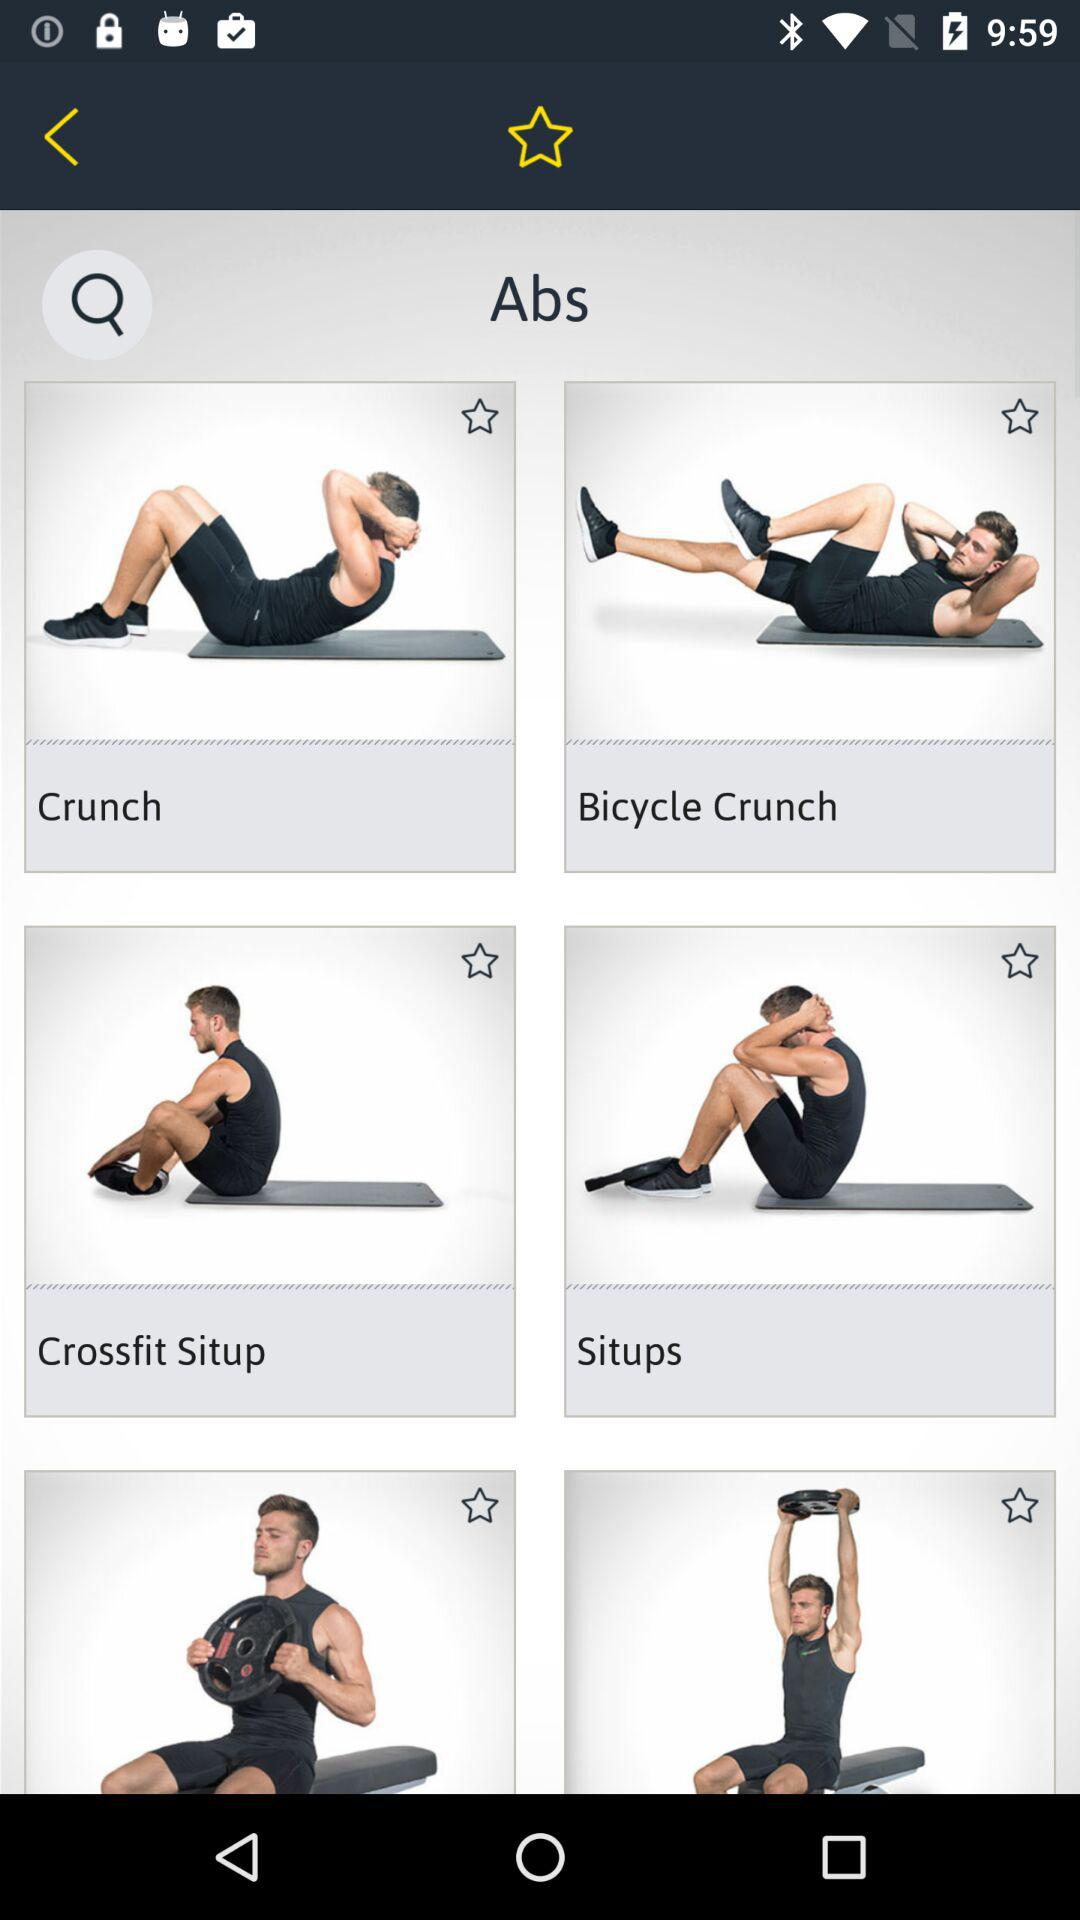Which part of the body is the exercise related to? The exercises are related to the abs. 